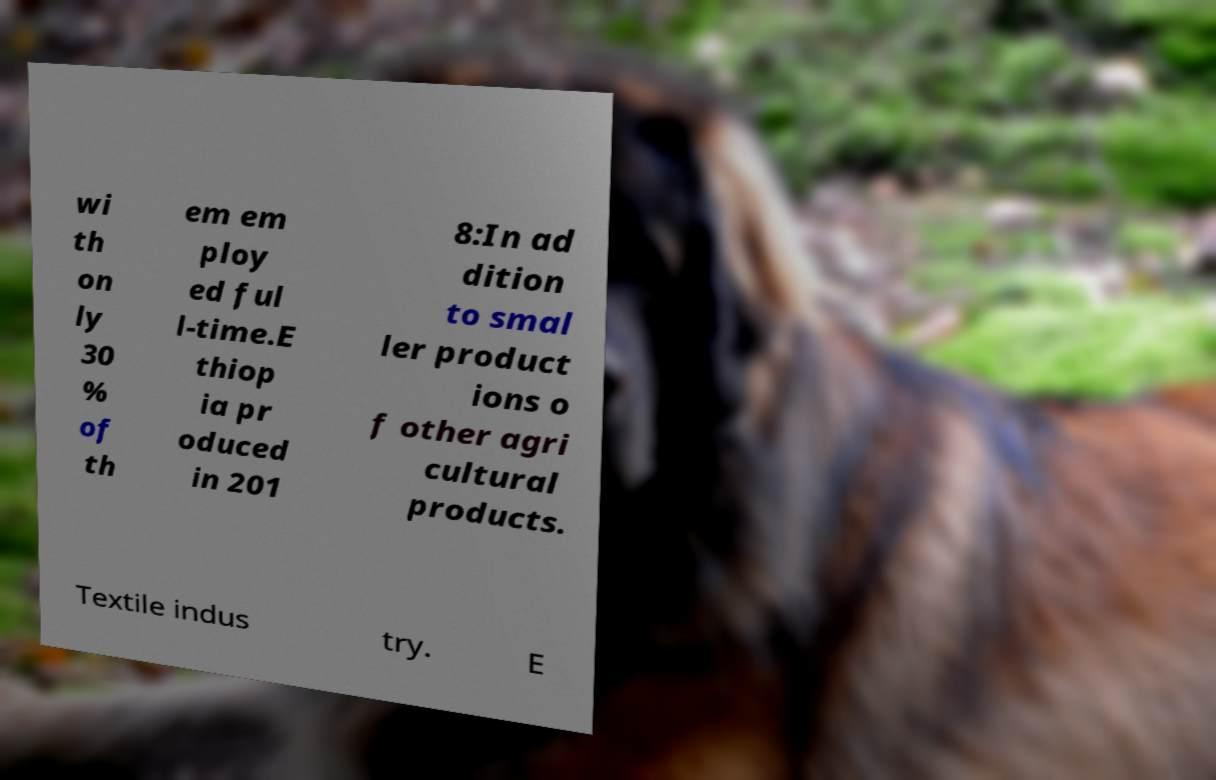Can you accurately transcribe the text from the provided image for me? wi th on ly 30 % of th em em ploy ed ful l-time.E thiop ia pr oduced in 201 8:In ad dition to smal ler product ions o f other agri cultural products. Textile indus try. E 